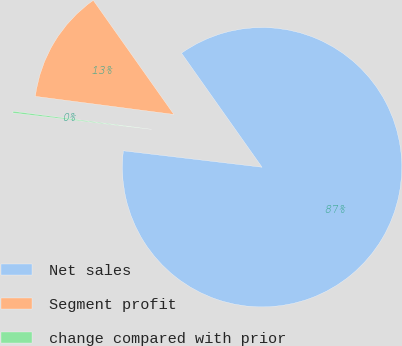Convert chart to OTSL. <chart><loc_0><loc_0><loc_500><loc_500><pie_chart><fcel>Net sales<fcel>Segment profit<fcel>change compared with prior<nl><fcel>86.66%<fcel>13.15%<fcel>0.19%<nl></chart> 